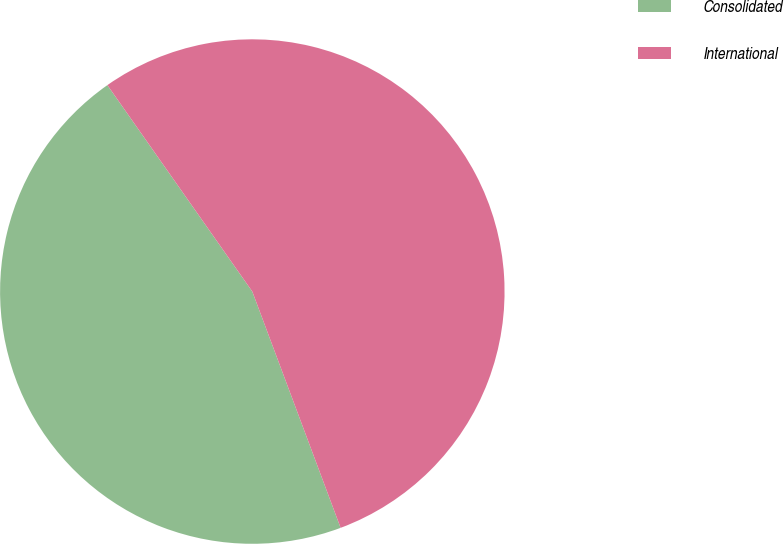Convert chart to OTSL. <chart><loc_0><loc_0><loc_500><loc_500><pie_chart><fcel>Consolidated<fcel>International<nl><fcel>45.95%<fcel>54.05%<nl></chart> 